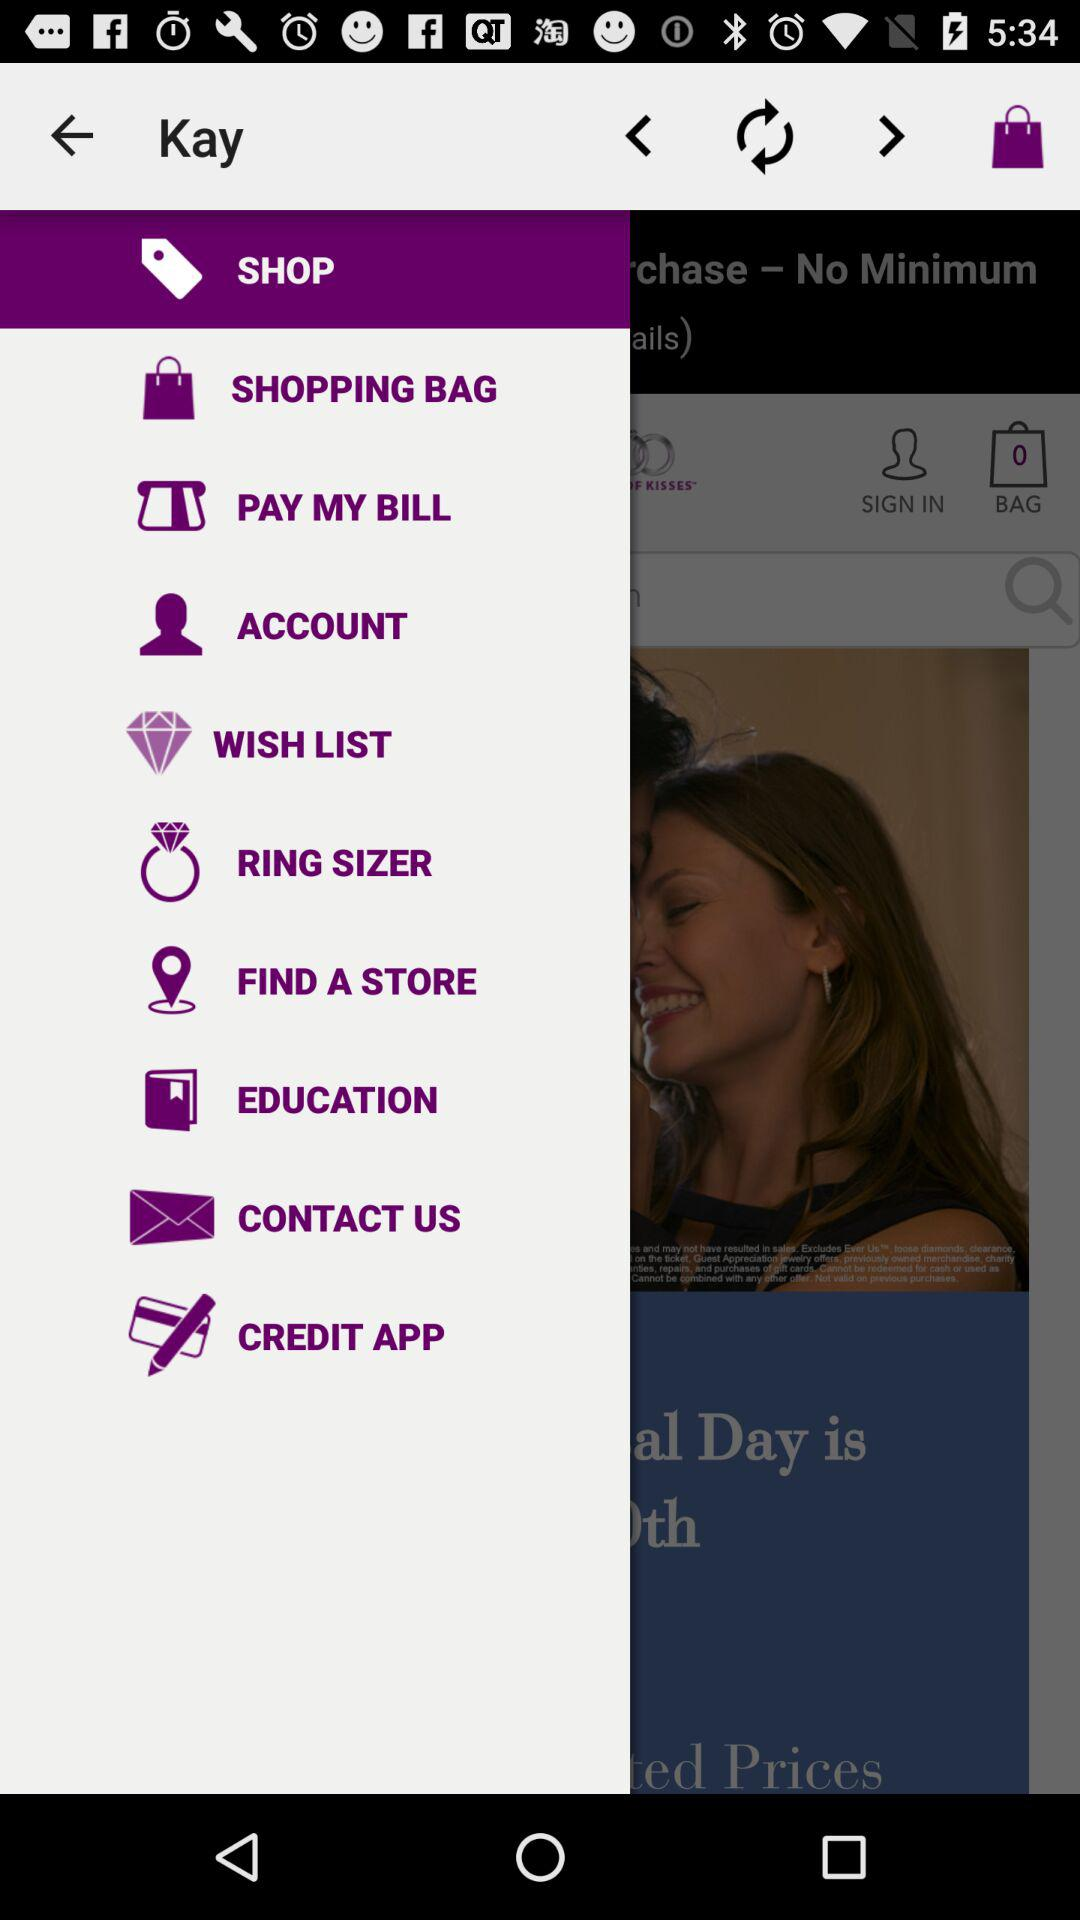Which option is selected? The selected option is "SHOP". 